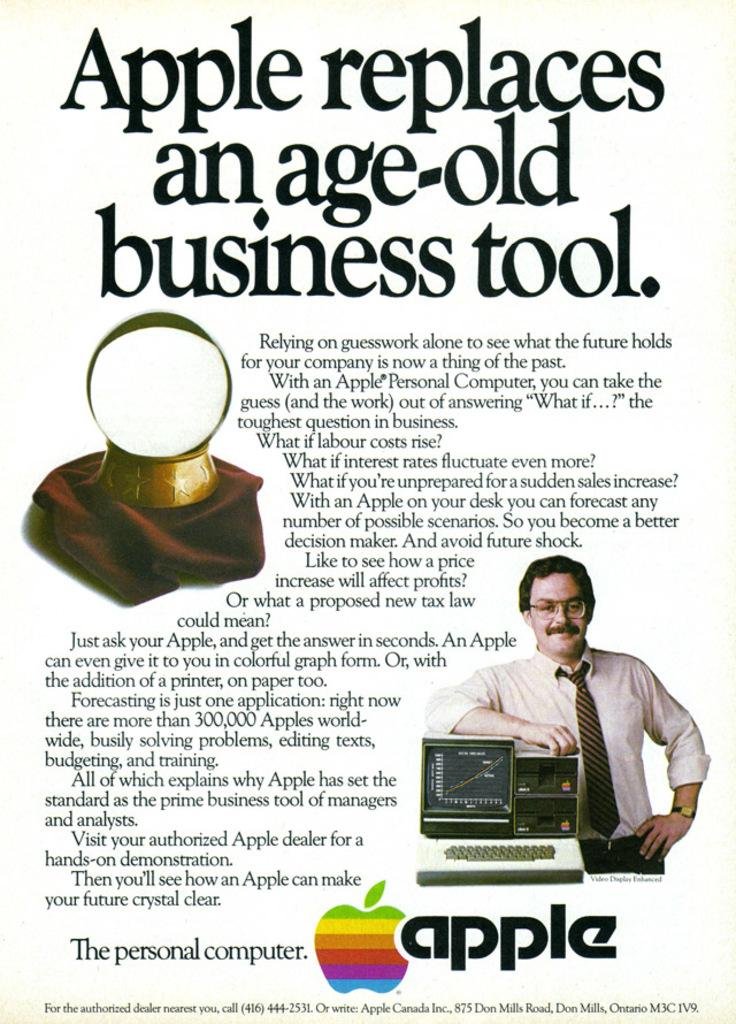<image>
Render a clear and concise summary of the photo. An old Apple computer ad says that Apples replace business school. 